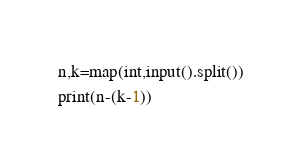<code> <loc_0><loc_0><loc_500><loc_500><_Python_>n,k=map(int,input().split())
print(n-(k-1))</code> 